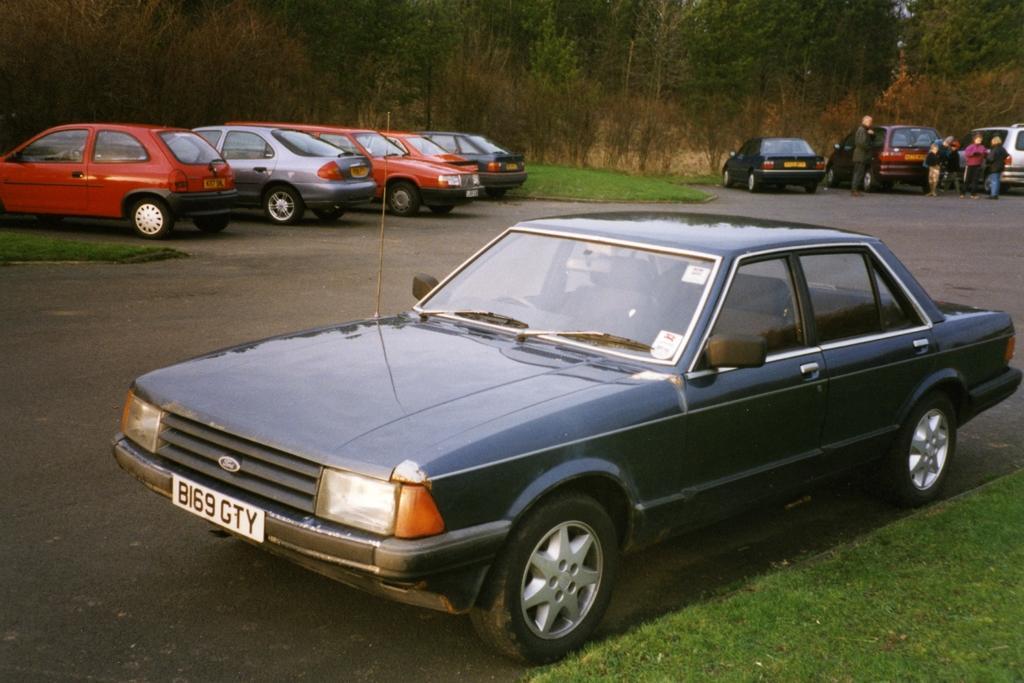Could you give a brief overview of what you see in this image? This picture is clicked outside. In the foreground we can see a car parked on the ground and we can see the green grass. In the center we can see the cars parked on the ground and we can see the group of people seems to be standing on the ground and we can see the green grass, plants and trees. 